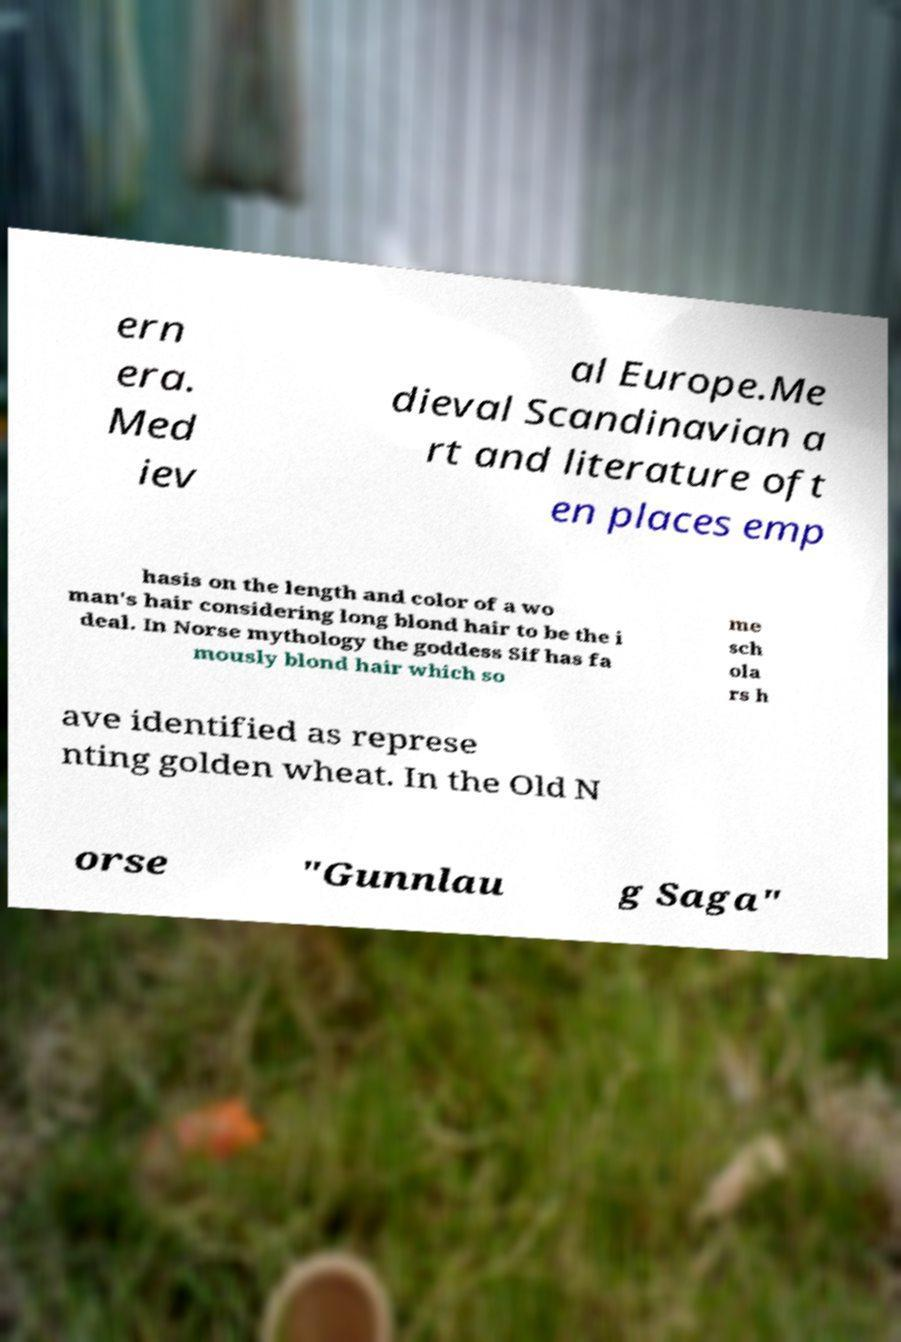Can you read and provide the text displayed in the image?This photo seems to have some interesting text. Can you extract and type it out for me? ern era. Med iev al Europe.Me dieval Scandinavian a rt and literature oft en places emp hasis on the length and color of a wo man's hair considering long blond hair to be the i deal. In Norse mythology the goddess Sif has fa mously blond hair which so me sch ola rs h ave identified as represe nting golden wheat. In the Old N orse "Gunnlau g Saga" 